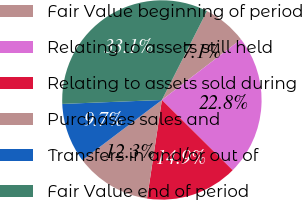Convert chart. <chart><loc_0><loc_0><loc_500><loc_500><pie_chart><fcel>Fair Value beginning of period<fcel>Relating to assets still held<fcel>Relating to assets sold during<fcel>Purchases sales and<fcel>Transfers in and/or out of<fcel>Fair Value end of period<nl><fcel>7.12%<fcel>22.85%<fcel>14.95%<fcel>12.31%<fcel>9.68%<fcel>33.1%<nl></chart> 